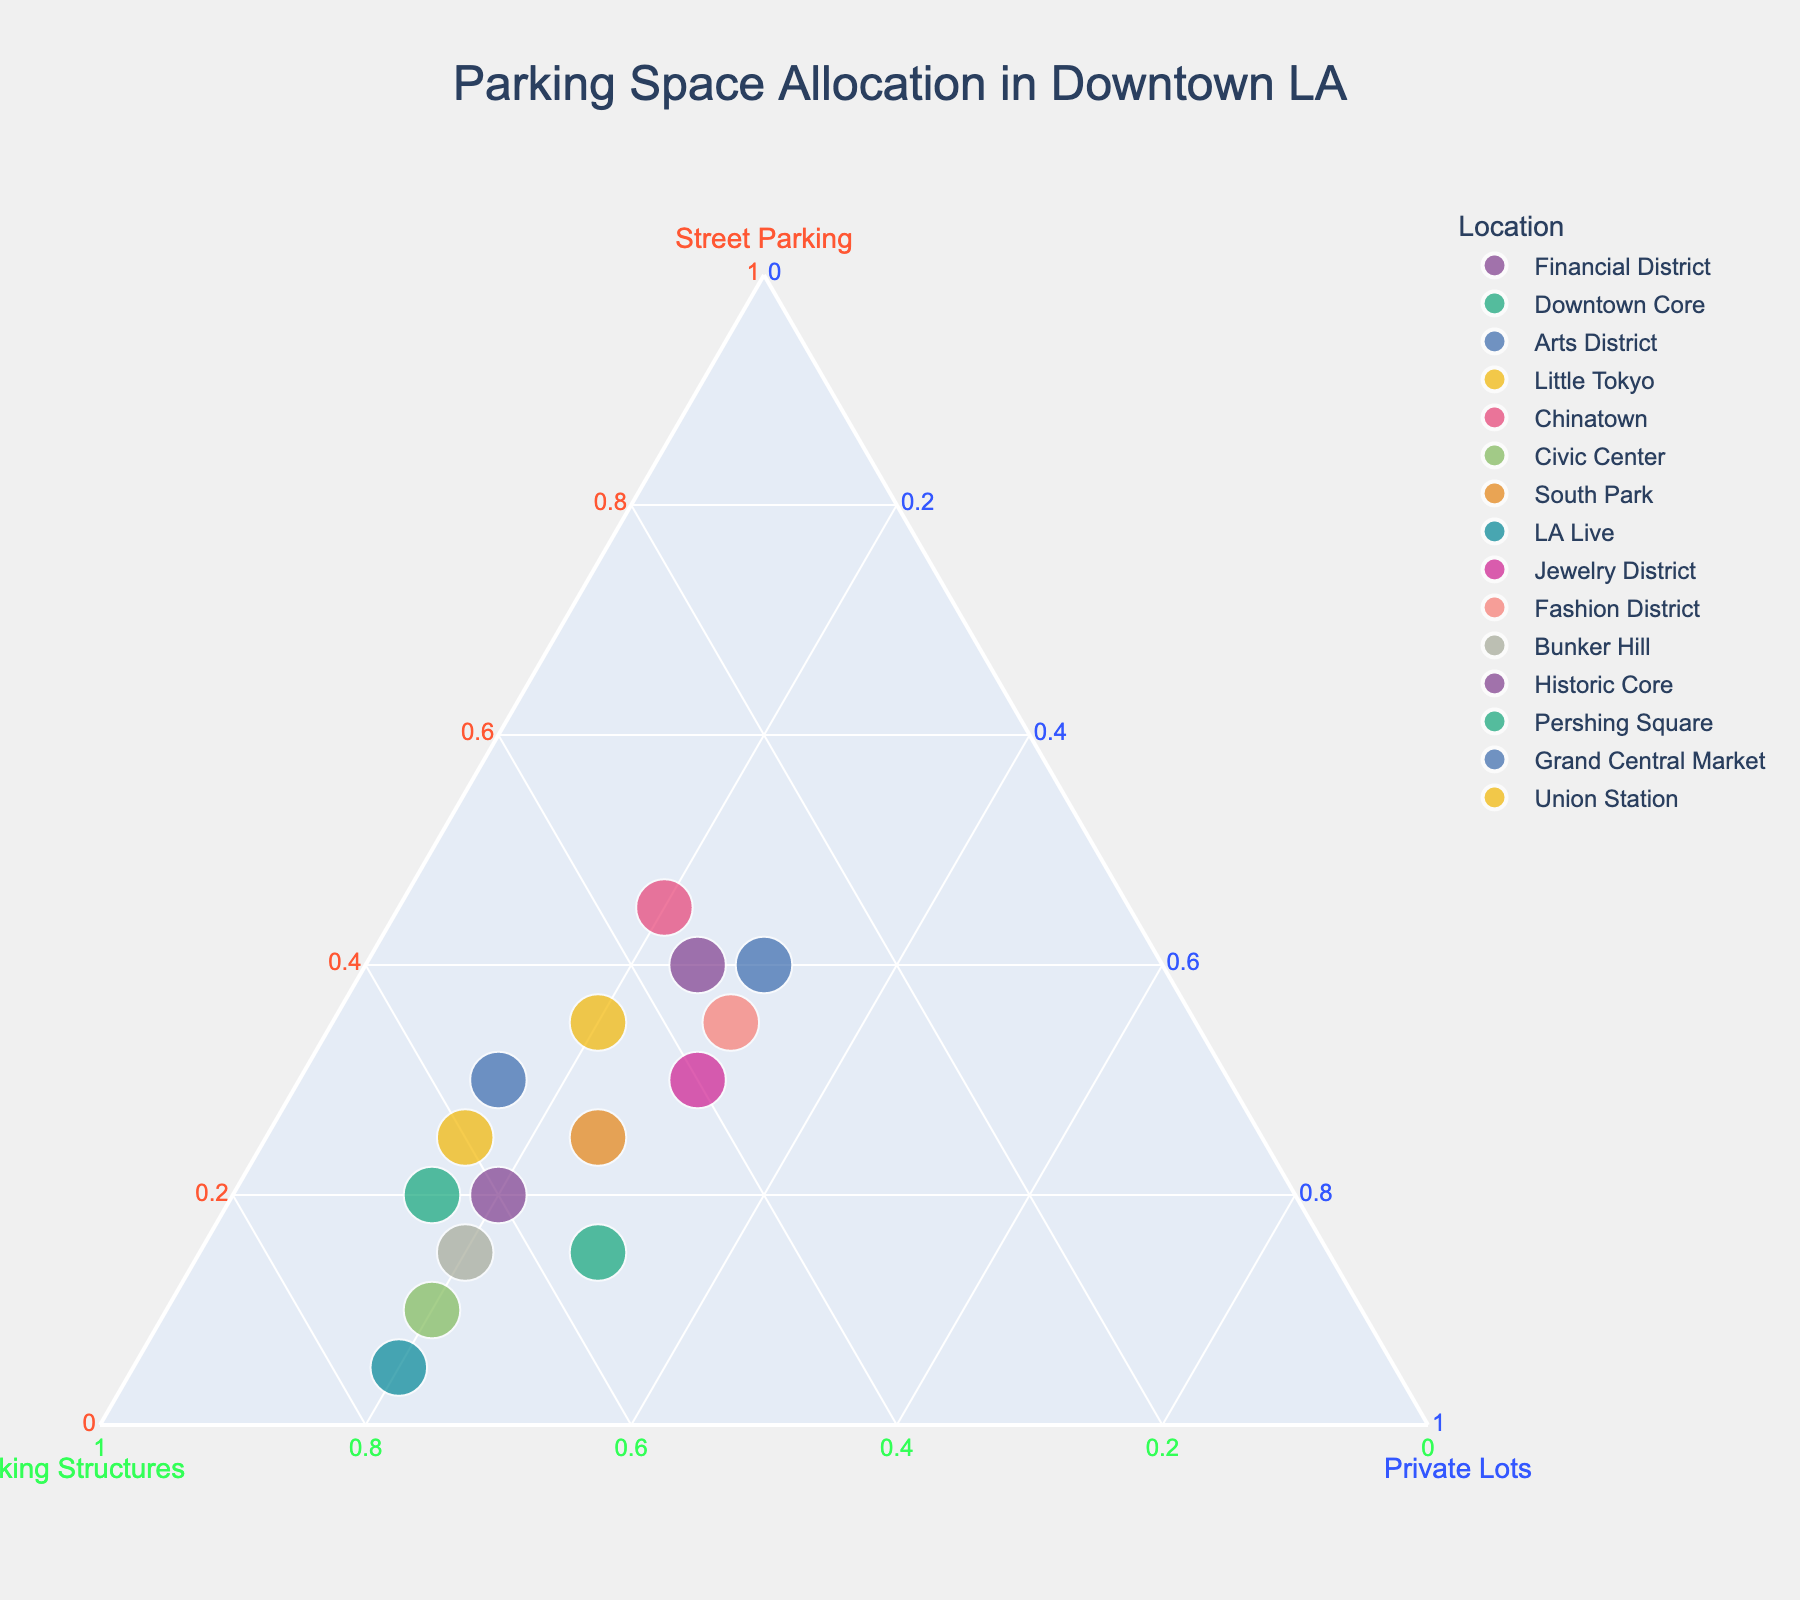what is the title of the plot? The title of the plot, typically found at the top, is: "Parking Space Allocation in Downtown LA."
Answer: Parking Space Allocation in Downtown LA Which location has the highest percentage of parking structures? Look for the dot closest to the "Parking Structures" axis, which represents the maximum value for that axis. LA Live has the highest percentage.
Answer: LA Live How many locations have the highest percentage of street parking? Identify the points closest to the "Street Parking" axis. The locations are Arts District, Chinatown, Historic Core, and Fashion District.
Answer: 4 Which category has the smallest percentage in the Financial District? For the Financial District, compare percentages of street parking, parking structures, and private lots. Both street parking and private lots are 20%, which are the smallest values.
Answer: Street Parking and Private Lots What is the sum of the percentages for street parking and private lots in South Park? In South Park, add the percentage of street parking (25%) and private lots (25%). The sum is 25 + 25 = 50.
Answer: 50 Which location has equal percentages of private lots and street parking? Check the annotations to identify locations where private lots percentage equals street parking percentage. Arts District has 40% both for private lots and street parking.
Answer: Arts District What is the range of parking structures percentage across all locations? Find the highest (LA Live - 75%) and lowest (Arts District - 30%) parking structures percentages and calculate the difference: 75 - 30.
Answer: 45 Which two locations have the same percentage for private lots? Identify the two locations that have the same percentage value for private lots. Downtown Core and Bunker Hill both have 20%.
Answer: Downtown Core and Bunker Hill Which location is closest to having an even split among all three parking types? Identify the point closest to the center of the ternary plot, indicating nearly equal values in all categories. The Fashion District with approximate values of (35, 35, 30) is closest.
Answer: Fashion District 